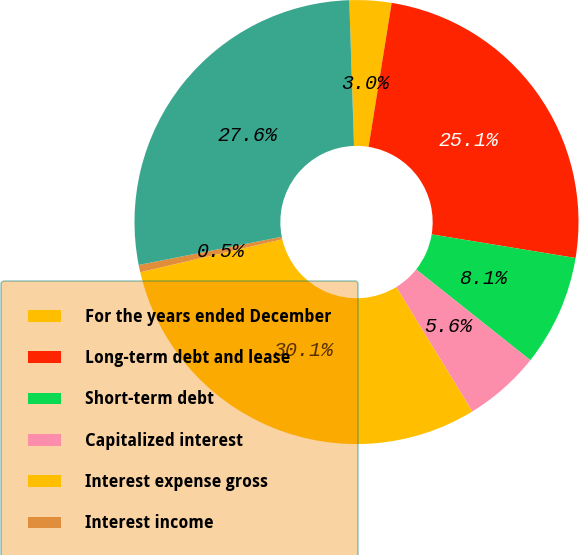Convert chart to OTSL. <chart><loc_0><loc_0><loc_500><loc_500><pie_chart><fcel>For the years ended December<fcel>Long-term debt and lease<fcel>Short-term debt<fcel>Capitalized interest<fcel>Interest expense gross<fcel>Interest income<fcel>Interest expense net<nl><fcel>3.05%<fcel>25.06%<fcel>8.1%<fcel>5.58%<fcel>30.11%<fcel>0.53%<fcel>27.58%<nl></chart> 